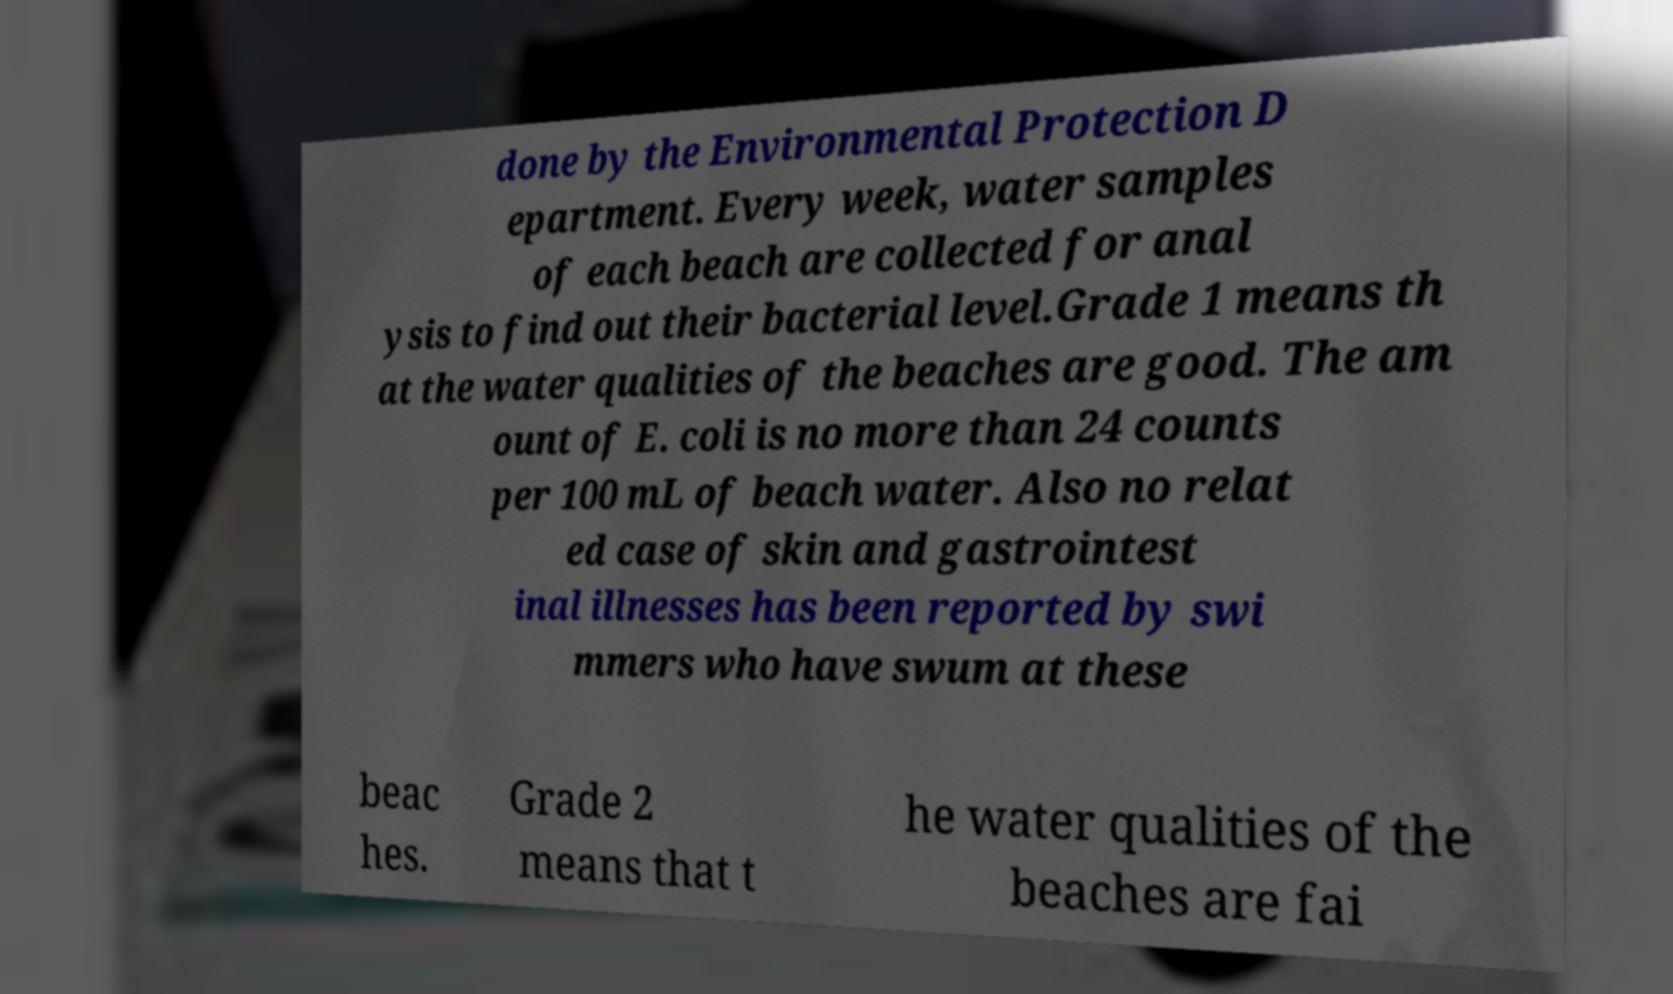Can you read and provide the text displayed in the image?This photo seems to have some interesting text. Can you extract and type it out for me? done by the Environmental Protection D epartment. Every week, water samples of each beach are collected for anal ysis to find out their bacterial level.Grade 1 means th at the water qualities of the beaches are good. The am ount of E. coli is no more than 24 counts per 100 mL of beach water. Also no relat ed case of skin and gastrointest inal illnesses has been reported by swi mmers who have swum at these beac hes. Grade 2 means that t he water qualities of the beaches are fai 